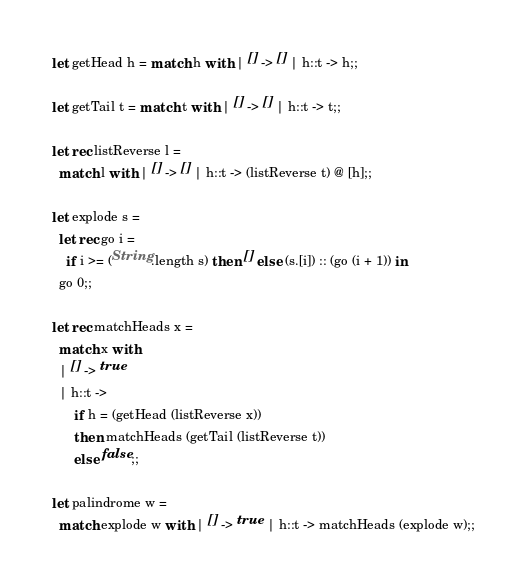Convert code to text. <code><loc_0><loc_0><loc_500><loc_500><_OCaml_>
let getHead h = match h with | [] -> [] | h::t -> h;;

let getTail t = match t with | [] -> [] | h::t -> t;;

let rec listReverse l =
  match l with | [] -> [] | h::t -> (listReverse t) @ [h];;

let explode s =
  let rec go i =
    if i >= (String.length s) then [] else (s.[i]) :: (go (i + 1)) in
  go 0;;

let rec matchHeads x =
  match x with
  | [] -> true
  | h::t ->
      if h = (getHead (listReverse x))
      then matchHeads (getTail (listReverse t))
      else false;;

let palindrome w =
  match explode w with | [] -> true | h::t -> matchHeads (explode w);;
</code> 